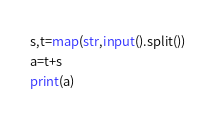<code> <loc_0><loc_0><loc_500><loc_500><_Python_>s,t=map(str,input().split())
a=t+s
print(a)


</code> 